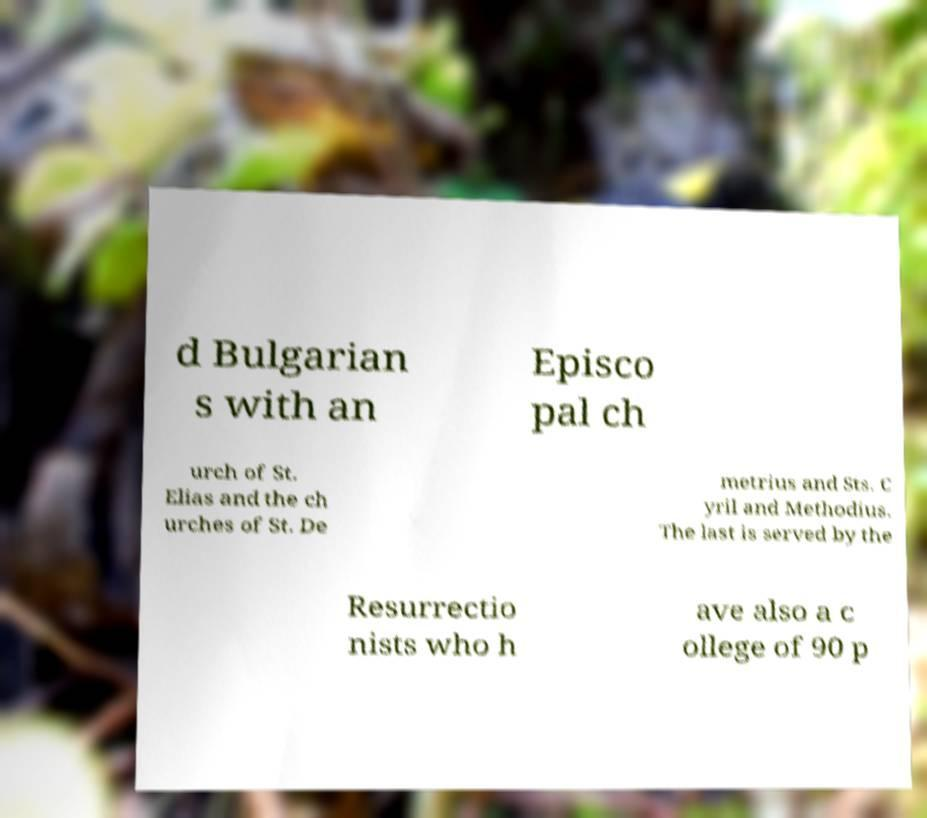Could you extract and type out the text from this image? d Bulgarian s with an Episco pal ch urch of St. Elias and the ch urches of St. De metrius and Sts. C yril and Methodius. The last is served by the Resurrectio nists who h ave also a c ollege of 90 p 